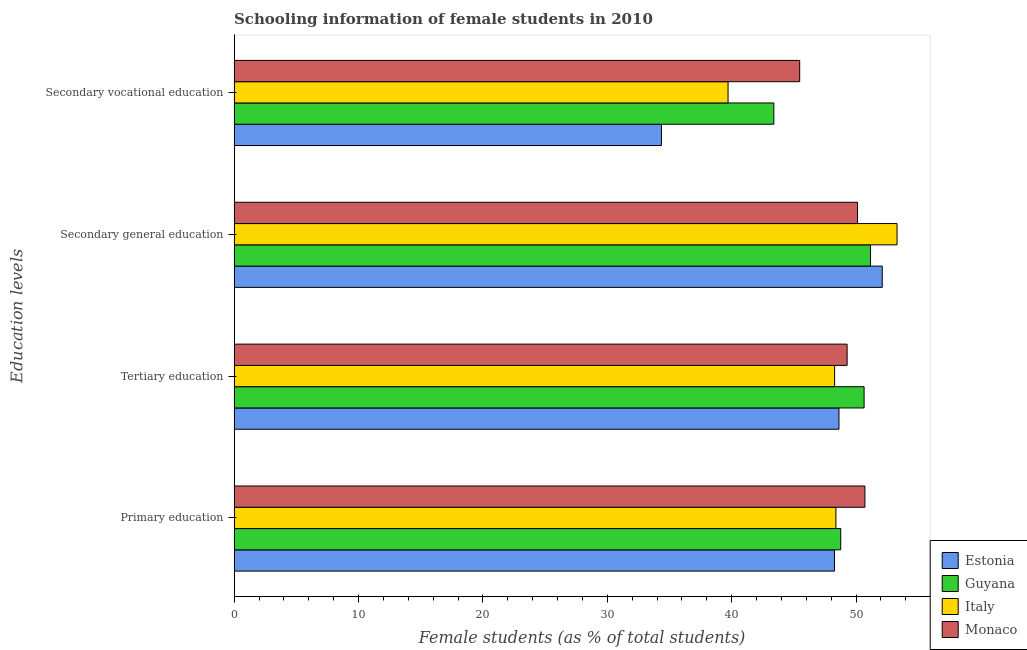How many different coloured bars are there?
Keep it short and to the point. 4. What is the percentage of female students in secondary vocational education in Estonia?
Offer a terse response. 34.36. Across all countries, what is the maximum percentage of female students in tertiary education?
Provide a succinct answer. 50.65. Across all countries, what is the minimum percentage of female students in secondary vocational education?
Give a very brief answer. 34.36. In which country was the percentage of female students in primary education maximum?
Offer a terse response. Monaco. In which country was the percentage of female students in secondary vocational education minimum?
Provide a short and direct response. Estonia. What is the total percentage of female students in secondary vocational education in the graph?
Your answer should be compact. 162.93. What is the difference between the percentage of female students in tertiary education in Monaco and that in Estonia?
Offer a very short reply. 0.65. What is the difference between the percentage of female students in primary education in Estonia and the percentage of female students in tertiary education in Italy?
Offer a very short reply. -0.01. What is the average percentage of female students in tertiary education per country?
Give a very brief answer. 49.21. What is the difference between the percentage of female students in primary education and percentage of female students in secondary vocational education in Guyana?
Keep it short and to the point. 5.38. What is the ratio of the percentage of female students in primary education in Estonia to that in Italy?
Offer a terse response. 1. Is the percentage of female students in tertiary education in Estonia less than that in Italy?
Ensure brevity in your answer.  No. What is the difference between the highest and the second highest percentage of female students in secondary vocational education?
Your answer should be compact. 2.08. What is the difference between the highest and the lowest percentage of female students in primary education?
Give a very brief answer. 2.44. In how many countries, is the percentage of female students in tertiary education greater than the average percentage of female students in tertiary education taken over all countries?
Give a very brief answer. 2. Is the sum of the percentage of female students in secondary education in Guyana and Monaco greater than the maximum percentage of female students in primary education across all countries?
Offer a very short reply. Yes. What does the 1st bar from the top in Secondary general education represents?
Your answer should be very brief. Monaco. What does the 4th bar from the bottom in Tertiary education represents?
Provide a succinct answer. Monaco. How many bars are there?
Offer a very short reply. 16. How many countries are there in the graph?
Give a very brief answer. 4. What is the difference between two consecutive major ticks on the X-axis?
Keep it short and to the point. 10. Where does the legend appear in the graph?
Provide a succinct answer. Bottom right. How are the legend labels stacked?
Make the answer very short. Vertical. What is the title of the graph?
Your response must be concise. Schooling information of female students in 2010. What is the label or title of the X-axis?
Keep it short and to the point. Female students (as % of total students). What is the label or title of the Y-axis?
Your response must be concise. Education levels. What is the Female students (as % of total students) of Estonia in Primary education?
Give a very brief answer. 48.27. What is the Female students (as % of total students) in Guyana in Primary education?
Offer a very short reply. 48.77. What is the Female students (as % of total students) in Italy in Primary education?
Give a very brief answer. 48.38. What is the Female students (as % of total students) of Monaco in Primary education?
Make the answer very short. 50.71. What is the Female students (as % of total students) of Estonia in Tertiary education?
Keep it short and to the point. 48.63. What is the Female students (as % of total students) of Guyana in Tertiary education?
Your answer should be compact. 50.65. What is the Female students (as % of total students) of Italy in Tertiary education?
Offer a very short reply. 48.28. What is the Female students (as % of total students) in Monaco in Tertiary education?
Give a very brief answer. 49.28. What is the Female students (as % of total students) of Estonia in Secondary general education?
Keep it short and to the point. 52.11. What is the Female students (as % of total students) in Guyana in Secondary general education?
Offer a terse response. 51.16. What is the Female students (as % of total students) in Italy in Secondary general education?
Give a very brief answer. 53.3. What is the Female students (as % of total students) in Monaco in Secondary general education?
Ensure brevity in your answer.  50.12. What is the Female students (as % of total students) in Estonia in Secondary vocational education?
Offer a terse response. 34.36. What is the Female students (as % of total students) of Guyana in Secondary vocational education?
Give a very brief answer. 43.39. What is the Female students (as % of total students) in Italy in Secondary vocational education?
Give a very brief answer. 39.71. What is the Female students (as % of total students) in Monaco in Secondary vocational education?
Your answer should be compact. 45.47. Across all Education levels, what is the maximum Female students (as % of total students) of Estonia?
Make the answer very short. 52.11. Across all Education levels, what is the maximum Female students (as % of total students) of Guyana?
Provide a short and direct response. 51.16. Across all Education levels, what is the maximum Female students (as % of total students) of Italy?
Keep it short and to the point. 53.3. Across all Education levels, what is the maximum Female students (as % of total students) in Monaco?
Offer a very short reply. 50.71. Across all Education levels, what is the minimum Female students (as % of total students) of Estonia?
Your answer should be very brief. 34.36. Across all Education levels, what is the minimum Female students (as % of total students) in Guyana?
Your answer should be very brief. 43.39. Across all Education levels, what is the minimum Female students (as % of total students) in Italy?
Offer a terse response. 39.71. Across all Education levels, what is the minimum Female students (as % of total students) in Monaco?
Provide a short and direct response. 45.47. What is the total Female students (as % of total students) in Estonia in the graph?
Offer a terse response. 183.37. What is the total Female students (as % of total students) in Guyana in the graph?
Offer a very short reply. 193.98. What is the total Female students (as % of total students) of Italy in the graph?
Keep it short and to the point. 189.68. What is the total Female students (as % of total students) in Monaco in the graph?
Make the answer very short. 195.59. What is the difference between the Female students (as % of total students) in Estonia in Primary education and that in Tertiary education?
Your answer should be compact. -0.36. What is the difference between the Female students (as % of total students) in Guyana in Primary education and that in Tertiary education?
Your answer should be compact. -1.88. What is the difference between the Female students (as % of total students) in Italy in Primary education and that in Tertiary education?
Give a very brief answer. 0.1. What is the difference between the Female students (as % of total students) in Monaco in Primary education and that in Tertiary education?
Offer a very short reply. 1.43. What is the difference between the Female students (as % of total students) of Estonia in Primary education and that in Secondary general education?
Your response must be concise. -3.84. What is the difference between the Female students (as % of total students) of Guyana in Primary education and that in Secondary general education?
Your response must be concise. -2.39. What is the difference between the Female students (as % of total students) of Italy in Primary education and that in Secondary general education?
Offer a very short reply. -4.91. What is the difference between the Female students (as % of total students) of Monaco in Primary education and that in Secondary general education?
Keep it short and to the point. 0.59. What is the difference between the Female students (as % of total students) of Estonia in Primary education and that in Secondary vocational education?
Offer a terse response. 13.91. What is the difference between the Female students (as % of total students) in Guyana in Primary education and that in Secondary vocational education?
Give a very brief answer. 5.38. What is the difference between the Female students (as % of total students) of Italy in Primary education and that in Secondary vocational education?
Your answer should be very brief. 8.67. What is the difference between the Female students (as % of total students) of Monaco in Primary education and that in Secondary vocational education?
Keep it short and to the point. 5.24. What is the difference between the Female students (as % of total students) of Estonia in Tertiary education and that in Secondary general education?
Your response must be concise. -3.48. What is the difference between the Female students (as % of total students) in Guyana in Tertiary education and that in Secondary general education?
Provide a succinct answer. -0.52. What is the difference between the Female students (as % of total students) in Italy in Tertiary education and that in Secondary general education?
Provide a succinct answer. -5.02. What is the difference between the Female students (as % of total students) in Monaco in Tertiary education and that in Secondary general education?
Provide a short and direct response. -0.84. What is the difference between the Female students (as % of total students) in Estonia in Tertiary education and that in Secondary vocational education?
Ensure brevity in your answer.  14.27. What is the difference between the Female students (as % of total students) in Guyana in Tertiary education and that in Secondary vocational education?
Ensure brevity in your answer.  7.26. What is the difference between the Female students (as % of total students) of Italy in Tertiary education and that in Secondary vocational education?
Ensure brevity in your answer.  8.57. What is the difference between the Female students (as % of total students) of Monaco in Tertiary education and that in Secondary vocational education?
Offer a terse response. 3.81. What is the difference between the Female students (as % of total students) of Estonia in Secondary general education and that in Secondary vocational education?
Make the answer very short. 17.75. What is the difference between the Female students (as % of total students) in Guyana in Secondary general education and that in Secondary vocational education?
Provide a succinct answer. 7.77. What is the difference between the Female students (as % of total students) of Italy in Secondary general education and that in Secondary vocational education?
Keep it short and to the point. 13.59. What is the difference between the Female students (as % of total students) of Monaco in Secondary general education and that in Secondary vocational education?
Provide a succinct answer. 4.65. What is the difference between the Female students (as % of total students) in Estonia in Primary education and the Female students (as % of total students) in Guyana in Tertiary education?
Keep it short and to the point. -2.38. What is the difference between the Female students (as % of total students) in Estonia in Primary education and the Female students (as % of total students) in Italy in Tertiary education?
Give a very brief answer. -0.01. What is the difference between the Female students (as % of total students) in Estonia in Primary education and the Female students (as % of total students) in Monaco in Tertiary education?
Offer a terse response. -1.01. What is the difference between the Female students (as % of total students) in Guyana in Primary education and the Female students (as % of total students) in Italy in Tertiary education?
Give a very brief answer. 0.49. What is the difference between the Female students (as % of total students) of Guyana in Primary education and the Female students (as % of total students) of Monaco in Tertiary education?
Make the answer very short. -0.51. What is the difference between the Female students (as % of total students) in Italy in Primary education and the Female students (as % of total students) in Monaco in Tertiary education?
Provide a succinct answer. -0.9. What is the difference between the Female students (as % of total students) in Estonia in Primary education and the Female students (as % of total students) in Guyana in Secondary general education?
Offer a very short reply. -2.89. What is the difference between the Female students (as % of total students) of Estonia in Primary education and the Female students (as % of total students) of Italy in Secondary general education?
Give a very brief answer. -5.03. What is the difference between the Female students (as % of total students) in Estonia in Primary education and the Female students (as % of total students) in Monaco in Secondary general education?
Offer a very short reply. -1.85. What is the difference between the Female students (as % of total students) in Guyana in Primary education and the Female students (as % of total students) in Italy in Secondary general education?
Provide a succinct answer. -4.53. What is the difference between the Female students (as % of total students) of Guyana in Primary education and the Female students (as % of total students) of Monaco in Secondary general education?
Keep it short and to the point. -1.35. What is the difference between the Female students (as % of total students) of Italy in Primary education and the Female students (as % of total students) of Monaco in Secondary general education?
Make the answer very short. -1.74. What is the difference between the Female students (as % of total students) in Estonia in Primary education and the Female students (as % of total students) in Guyana in Secondary vocational education?
Offer a terse response. 4.88. What is the difference between the Female students (as % of total students) in Estonia in Primary education and the Female students (as % of total students) in Italy in Secondary vocational education?
Ensure brevity in your answer.  8.56. What is the difference between the Female students (as % of total students) of Estonia in Primary education and the Female students (as % of total students) of Monaco in Secondary vocational education?
Offer a very short reply. 2.8. What is the difference between the Female students (as % of total students) of Guyana in Primary education and the Female students (as % of total students) of Italy in Secondary vocational education?
Offer a terse response. 9.06. What is the difference between the Female students (as % of total students) in Guyana in Primary education and the Female students (as % of total students) in Monaco in Secondary vocational education?
Keep it short and to the point. 3.3. What is the difference between the Female students (as % of total students) of Italy in Primary education and the Female students (as % of total students) of Monaco in Secondary vocational education?
Your answer should be very brief. 2.91. What is the difference between the Female students (as % of total students) in Estonia in Tertiary education and the Female students (as % of total students) in Guyana in Secondary general education?
Make the answer very short. -2.54. What is the difference between the Female students (as % of total students) in Estonia in Tertiary education and the Female students (as % of total students) in Italy in Secondary general education?
Your answer should be compact. -4.67. What is the difference between the Female students (as % of total students) in Estonia in Tertiary education and the Female students (as % of total students) in Monaco in Secondary general education?
Provide a succinct answer. -1.49. What is the difference between the Female students (as % of total students) of Guyana in Tertiary education and the Female students (as % of total students) of Italy in Secondary general education?
Your response must be concise. -2.65. What is the difference between the Female students (as % of total students) of Guyana in Tertiary education and the Female students (as % of total students) of Monaco in Secondary general education?
Offer a very short reply. 0.53. What is the difference between the Female students (as % of total students) in Italy in Tertiary education and the Female students (as % of total students) in Monaco in Secondary general education?
Offer a terse response. -1.84. What is the difference between the Female students (as % of total students) in Estonia in Tertiary education and the Female students (as % of total students) in Guyana in Secondary vocational education?
Your answer should be compact. 5.24. What is the difference between the Female students (as % of total students) of Estonia in Tertiary education and the Female students (as % of total students) of Italy in Secondary vocational education?
Provide a succinct answer. 8.92. What is the difference between the Female students (as % of total students) in Estonia in Tertiary education and the Female students (as % of total students) in Monaco in Secondary vocational education?
Your response must be concise. 3.16. What is the difference between the Female students (as % of total students) of Guyana in Tertiary education and the Female students (as % of total students) of Italy in Secondary vocational education?
Offer a very short reply. 10.94. What is the difference between the Female students (as % of total students) in Guyana in Tertiary education and the Female students (as % of total students) in Monaco in Secondary vocational education?
Your response must be concise. 5.18. What is the difference between the Female students (as % of total students) of Italy in Tertiary education and the Female students (as % of total students) of Monaco in Secondary vocational education?
Provide a succinct answer. 2.81. What is the difference between the Female students (as % of total students) of Estonia in Secondary general education and the Female students (as % of total students) of Guyana in Secondary vocational education?
Your answer should be very brief. 8.72. What is the difference between the Female students (as % of total students) in Estonia in Secondary general education and the Female students (as % of total students) in Italy in Secondary vocational education?
Give a very brief answer. 12.4. What is the difference between the Female students (as % of total students) of Estonia in Secondary general education and the Female students (as % of total students) of Monaco in Secondary vocational education?
Provide a succinct answer. 6.64. What is the difference between the Female students (as % of total students) in Guyana in Secondary general education and the Female students (as % of total students) in Italy in Secondary vocational education?
Your answer should be compact. 11.45. What is the difference between the Female students (as % of total students) of Guyana in Secondary general education and the Female students (as % of total students) of Monaco in Secondary vocational education?
Give a very brief answer. 5.69. What is the difference between the Female students (as % of total students) of Italy in Secondary general education and the Female students (as % of total students) of Monaco in Secondary vocational education?
Ensure brevity in your answer.  7.83. What is the average Female students (as % of total students) of Estonia per Education levels?
Your answer should be very brief. 45.84. What is the average Female students (as % of total students) in Guyana per Education levels?
Offer a very short reply. 48.49. What is the average Female students (as % of total students) in Italy per Education levels?
Offer a very short reply. 47.42. What is the average Female students (as % of total students) of Monaco per Education levels?
Provide a succinct answer. 48.9. What is the difference between the Female students (as % of total students) in Estonia and Female students (as % of total students) in Italy in Primary education?
Keep it short and to the point. -0.11. What is the difference between the Female students (as % of total students) in Estonia and Female students (as % of total students) in Monaco in Primary education?
Your answer should be compact. -2.44. What is the difference between the Female students (as % of total students) in Guyana and Female students (as % of total students) in Italy in Primary education?
Your answer should be very brief. 0.39. What is the difference between the Female students (as % of total students) in Guyana and Female students (as % of total students) in Monaco in Primary education?
Ensure brevity in your answer.  -1.94. What is the difference between the Female students (as % of total students) of Italy and Female students (as % of total students) of Monaco in Primary education?
Give a very brief answer. -2.33. What is the difference between the Female students (as % of total students) of Estonia and Female students (as % of total students) of Guyana in Tertiary education?
Provide a short and direct response. -2.02. What is the difference between the Female students (as % of total students) in Estonia and Female students (as % of total students) in Italy in Tertiary education?
Offer a very short reply. 0.35. What is the difference between the Female students (as % of total students) of Estonia and Female students (as % of total students) of Monaco in Tertiary education?
Give a very brief answer. -0.65. What is the difference between the Female students (as % of total students) of Guyana and Female students (as % of total students) of Italy in Tertiary education?
Keep it short and to the point. 2.37. What is the difference between the Female students (as % of total students) of Guyana and Female students (as % of total students) of Monaco in Tertiary education?
Offer a very short reply. 1.37. What is the difference between the Female students (as % of total students) in Italy and Female students (as % of total students) in Monaco in Tertiary education?
Your response must be concise. -1. What is the difference between the Female students (as % of total students) in Estonia and Female students (as % of total students) in Guyana in Secondary general education?
Offer a terse response. 0.94. What is the difference between the Female students (as % of total students) in Estonia and Female students (as % of total students) in Italy in Secondary general education?
Give a very brief answer. -1.19. What is the difference between the Female students (as % of total students) in Estonia and Female students (as % of total students) in Monaco in Secondary general education?
Provide a short and direct response. 1.99. What is the difference between the Female students (as % of total students) of Guyana and Female students (as % of total students) of Italy in Secondary general education?
Provide a succinct answer. -2.13. What is the difference between the Female students (as % of total students) of Guyana and Female students (as % of total students) of Monaco in Secondary general education?
Ensure brevity in your answer.  1.04. What is the difference between the Female students (as % of total students) of Italy and Female students (as % of total students) of Monaco in Secondary general education?
Provide a succinct answer. 3.18. What is the difference between the Female students (as % of total students) of Estonia and Female students (as % of total students) of Guyana in Secondary vocational education?
Offer a very short reply. -9.03. What is the difference between the Female students (as % of total students) of Estonia and Female students (as % of total students) of Italy in Secondary vocational education?
Offer a very short reply. -5.35. What is the difference between the Female students (as % of total students) of Estonia and Female students (as % of total students) of Monaco in Secondary vocational education?
Keep it short and to the point. -11.11. What is the difference between the Female students (as % of total students) in Guyana and Female students (as % of total students) in Italy in Secondary vocational education?
Provide a succinct answer. 3.68. What is the difference between the Female students (as % of total students) of Guyana and Female students (as % of total students) of Monaco in Secondary vocational education?
Keep it short and to the point. -2.08. What is the difference between the Female students (as % of total students) of Italy and Female students (as % of total students) of Monaco in Secondary vocational education?
Offer a very short reply. -5.76. What is the ratio of the Female students (as % of total students) of Estonia in Primary education to that in Tertiary education?
Your answer should be compact. 0.99. What is the ratio of the Female students (as % of total students) in Guyana in Primary education to that in Tertiary education?
Your answer should be compact. 0.96. What is the ratio of the Female students (as % of total students) in Italy in Primary education to that in Tertiary education?
Your response must be concise. 1. What is the ratio of the Female students (as % of total students) of Monaco in Primary education to that in Tertiary education?
Provide a short and direct response. 1.03. What is the ratio of the Female students (as % of total students) in Estonia in Primary education to that in Secondary general education?
Your response must be concise. 0.93. What is the ratio of the Female students (as % of total students) of Guyana in Primary education to that in Secondary general education?
Offer a very short reply. 0.95. What is the ratio of the Female students (as % of total students) in Italy in Primary education to that in Secondary general education?
Offer a very short reply. 0.91. What is the ratio of the Female students (as % of total students) in Monaco in Primary education to that in Secondary general education?
Ensure brevity in your answer.  1.01. What is the ratio of the Female students (as % of total students) in Estonia in Primary education to that in Secondary vocational education?
Offer a very short reply. 1.41. What is the ratio of the Female students (as % of total students) in Guyana in Primary education to that in Secondary vocational education?
Provide a short and direct response. 1.12. What is the ratio of the Female students (as % of total students) in Italy in Primary education to that in Secondary vocational education?
Ensure brevity in your answer.  1.22. What is the ratio of the Female students (as % of total students) in Monaco in Primary education to that in Secondary vocational education?
Keep it short and to the point. 1.12. What is the ratio of the Female students (as % of total students) in Estonia in Tertiary education to that in Secondary general education?
Offer a very short reply. 0.93. What is the ratio of the Female students (as % of total students) in Guyana in Tertiary education to that in Secondary general education?
Give a very brief answer. 0.99. What is the ratio of the Female students (as % of total students) of Italy in Tertiary education to that in Secondary general education?
Your answer should be very brief. 0.91. What is the ratio of the Female students (as % of total students) of Monaco in Tertiary education to that in Secondary general education?
Offer a terse response. 0.98. What is the ratio of the Female students (as % of total students) in Estonia in Tertiary education to that in Secondary vocational education?
Give a very brief answer. 1.42. What is the ratio of the Female students (as % of total students) of Guyana in Tertiary education to that in Secondary vocational education?
Provide a succinct answer. 1.17. What is the ratio of the Female students (as % of total students) in Italy in Tertiary education to that in Secondary vocational education?
Keep it short and to the point. 1.22. What is the ratio of the Female students (as % of total students) of Monaco in Tertiary education to that in Secondary vocational education?
Keep it short and to the point. 1.08. What is the ratio of the Female students (as % of total students) in Estonia in Secondary general education to that in Secondary vocational education?
Make the answer very short. 1.52. What is the ratio of the Female students (as % of total students) of Guyana in Secondary general education to that in Secondary vocational education?
Offer a very short reply. 1.18. What is the ratio of the Female students (as % of total students) of Italy in Secondary general education to that in Secondary vocational education?
Offer a terse response. 1.34. What is the ratio of the Female students (as % of total students) of Monaco in Secondary general education to that in Secondary vocational education?
Provide a short and direct response. 1.1. What is the difference between the highest and the second highest Female students (as % of total students) in Estonia?
Offer a very short reply. 3.48. What is the difference between the highest and the second highest Female students (as % of total students) of Guyana?
Give a very brief answer. 0.52. What is the difference between the highest and the second highest Female students (as % of total students) of Italy?
Your answer should be very brief. 4.91. What is the difference between the highest and the second highest Female students (as % of total students) in Monaco?
Offer a very short reply. 0.59. What is the difference between the highest and the lowest Female students (as % of total students) of Estonia?
Offer a terse response. 17.75. What is the difference between the highest and the lowest Female students (as % of total students) of Guyana?
Make the answer very short. 7.77. What is the difference between the highest and the lowest Female students (as % of total students) of Italy?
Provide a succinct answer. 13.59. What is the difference between the highest and the lowest Female students (as % of total students) of Monaco?
Provide a succinct answer. 5.24. 